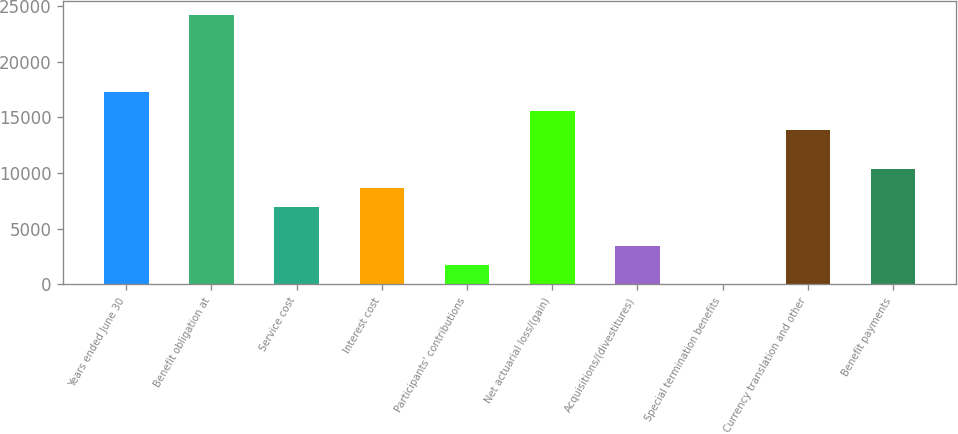<chart> <loc_0><loc_0><loc_500><loc_500><bar_chart><fcel>Years ended June 30<fcel>Benefit obligation at<fcel>Service cost<fcel>Interest cost<fcel>Participants' contributions<fcel>Net actuarial loss/(gain)<fcel>Acquisitions/(divestitures)<fcel>Special termination benefits<fcel>Currency translation and other<fcel>Benefit payments<nl><fcel>17285<fcel>24196.6<fcel>6917.6<fcel>8645.5<fcel>1733.9<fcel>15557.1<fcel>3461.8<fcel>6<fcel>13829.2<fcel>10373.4<nl></chart> 